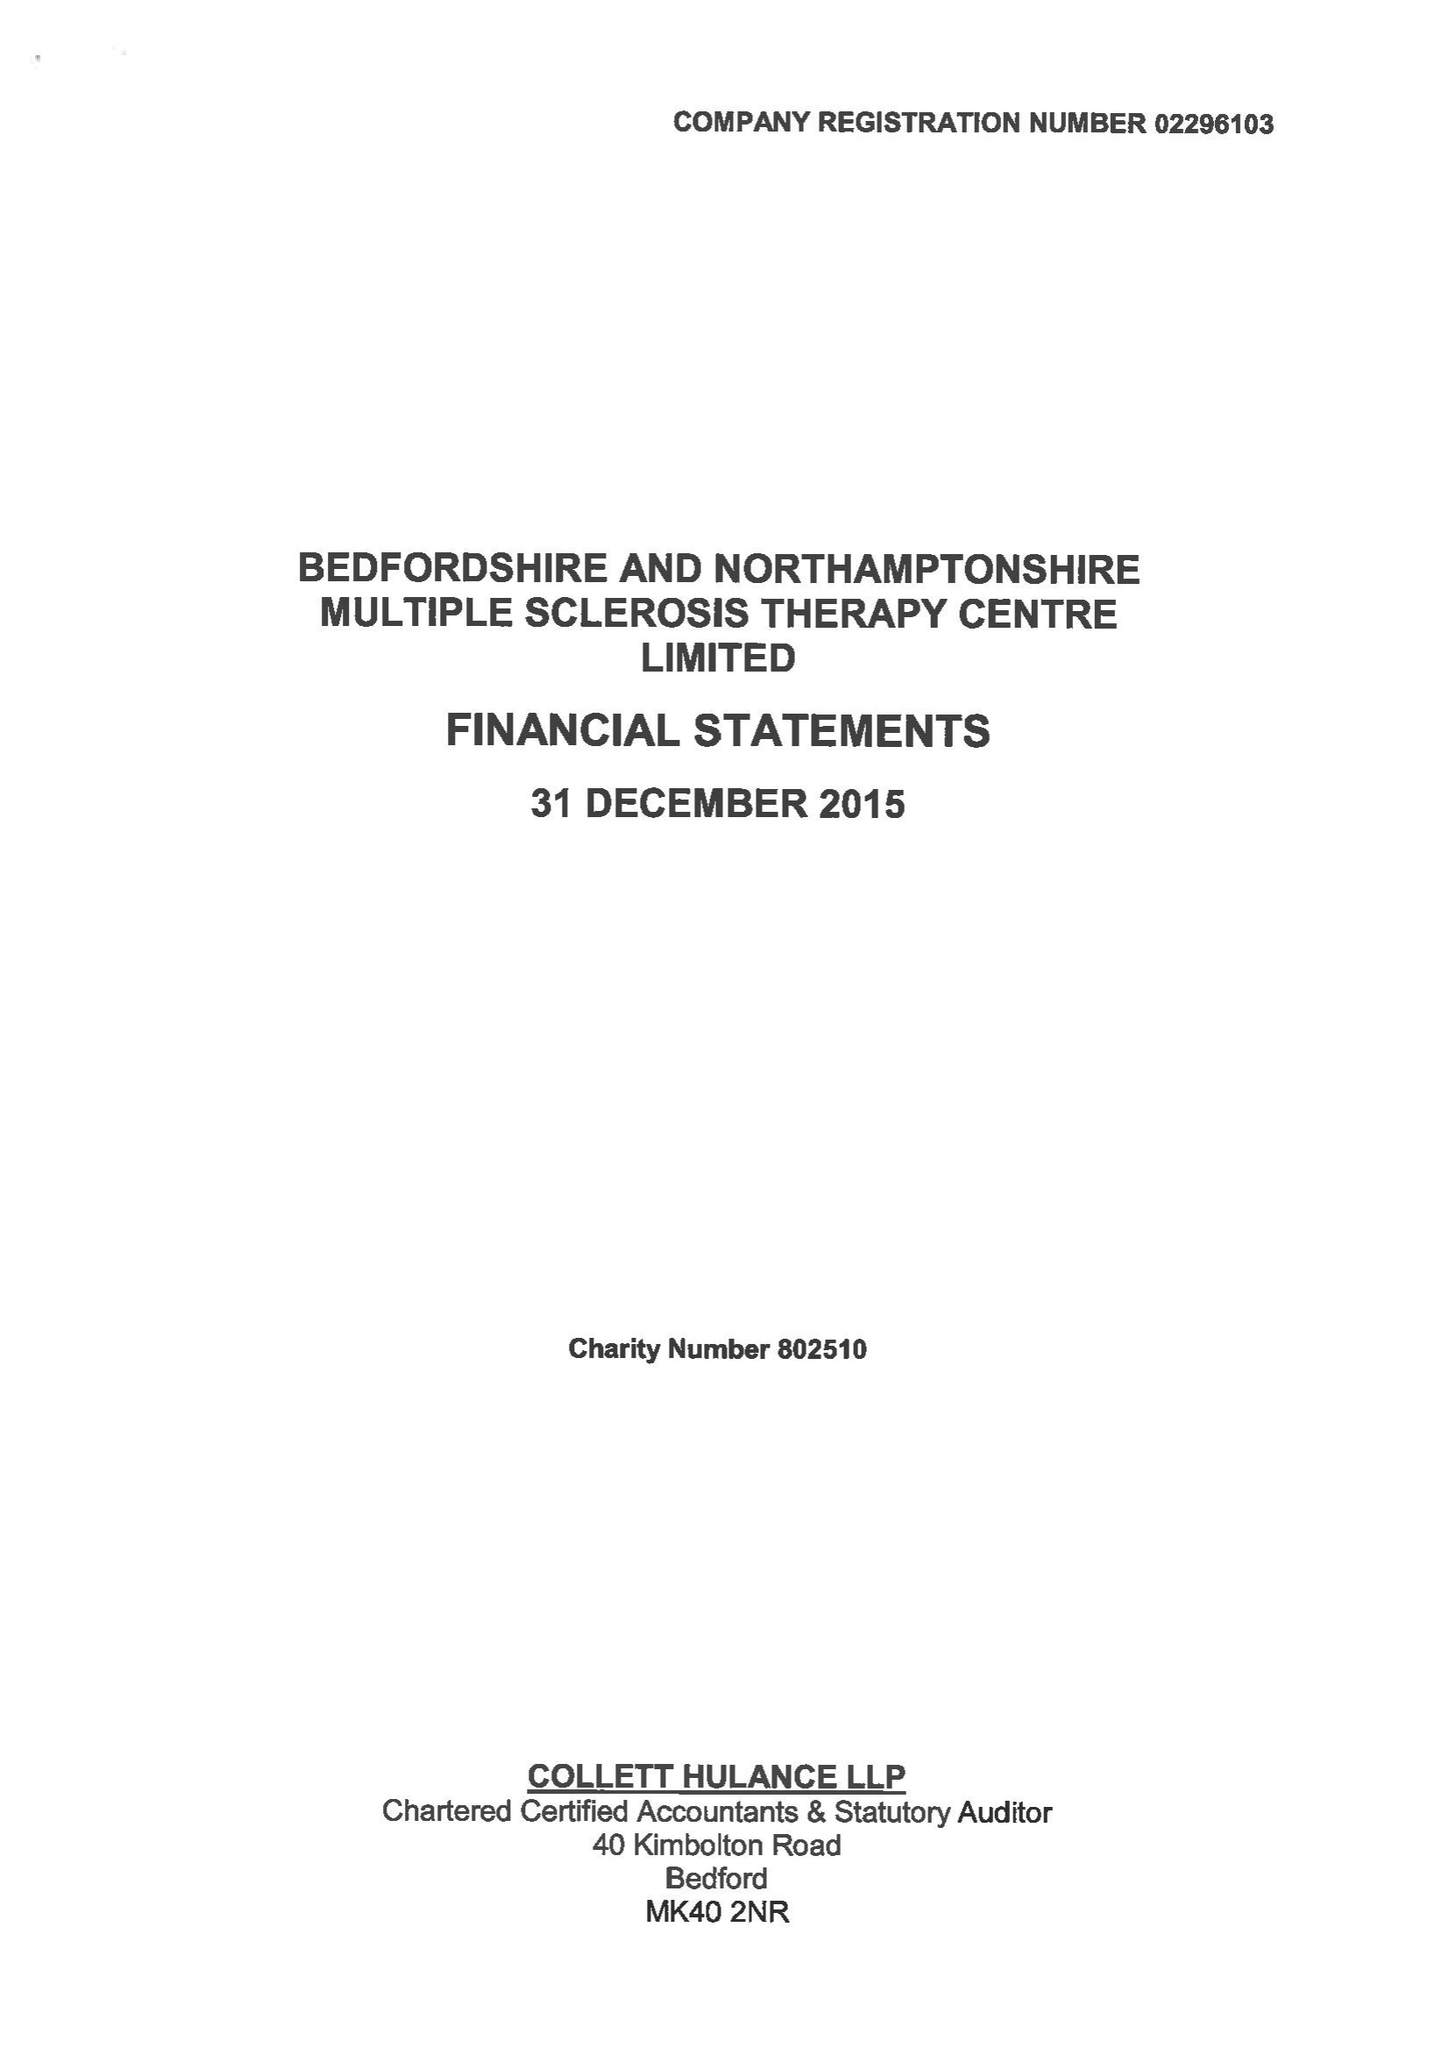What is the value for the spending_annually_in_british_pounds?
Answer the question using a single word or phrase. 404934.00 